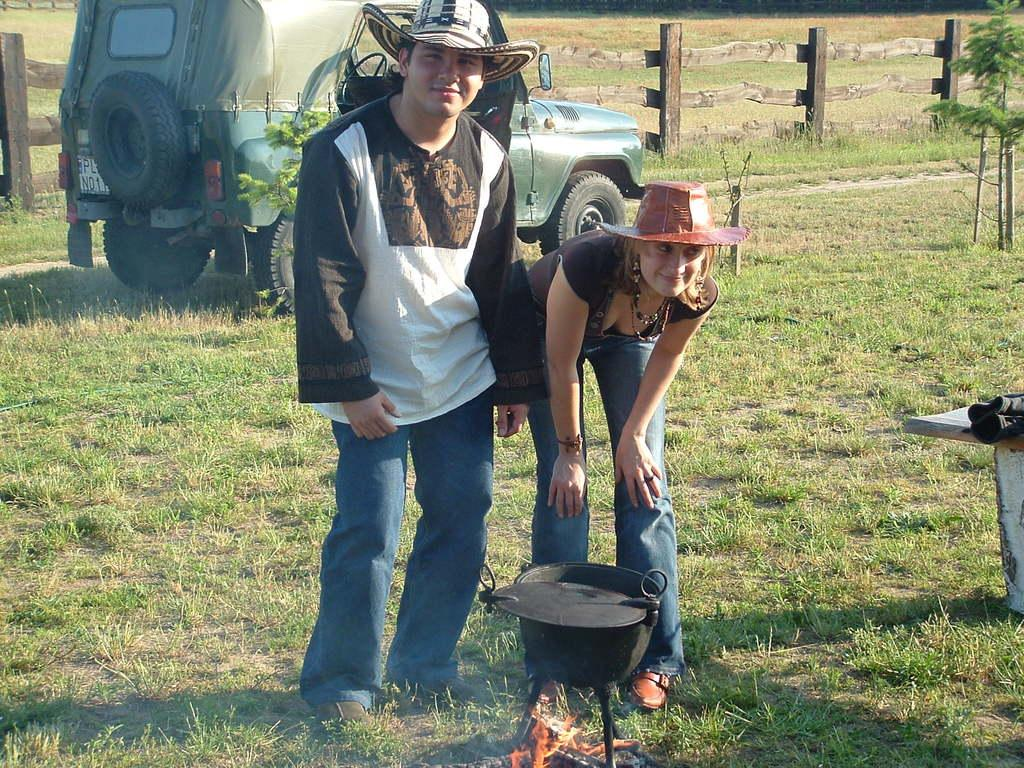What activity is taking place in the image? Cooking is happening on fire in the image. Can you describe the people in the image? There are persons standing on the ground in the image. What type of vehicle can be seen in the image? A motor vehicle is visible in the image. What is the barrier made of in the image? There is a wooden fence in the image. What type of living organisms are present in the image? Plants are present in the image. What type of glass is being used by the band in the image? There is no band present in the image, so it is not possible to determine what type of glass they might be using. 